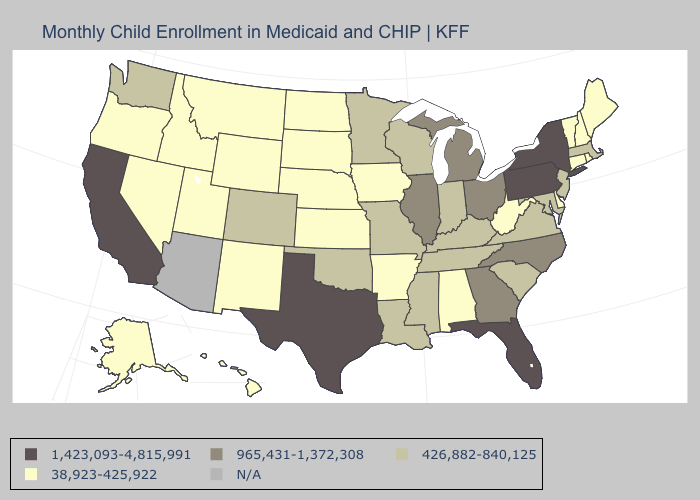Does Ohio have the lowest value in the MidWest?
Be succinct. No. Name the states that have a value in the range 1,423,093-4,815,991?
Keep it brief. California, Florida, New York, Pennsylvania, Texas. Which states hav the highest value in the MidWest?
Quick response, please. Illinois, Michigan, Ohio. Does Pennsylvania have the lowest value in the Northeast?
Short answer required. No. What is the value of Missouri?
Write a very short answer. 426,882-840,125. Which states have the lowest value in the West?
Give a very brief answer. Alaska, Hawaii, Idaho, Montana, Nevada, New Mexico, Oregon, Utah, Wyoming. Name the states that have a value in the range N/A?
Answer briefly. Arizona. Among the states that border New Hampshire , does Maine have the highest value?
Give a very brief answer. No. Which states have the lowest value in the South?
Keep it brief. Alabama, Arkansas, Delaware, West Virginia. What is the value of Alaska?
Quick response, please. 38,923-425,922. Among the states that border Florida , which have the highest value?
Concise answer only. Georgia. Which states have the lowest value in the West?
Keep it brief. Alaska, Hawaii, Idaho, Montana, Nevada, New Mexico, Oregon, Utah, Wyoming. Name the states that have a value in the range 426,882-840,125?
Be succinct. Colorado, Indiana, Kentucky, Louisiana, Maryland, Massachusetts, Minnesota, Mississippi, Missouri, New Jersey, Oklahoma, South Carolina, Tennessee, Virginia, Washington, Wisconsin. Among the states that border New Hampshire , which have the lowest value?
Keep it brief. Maine, Vermont. 